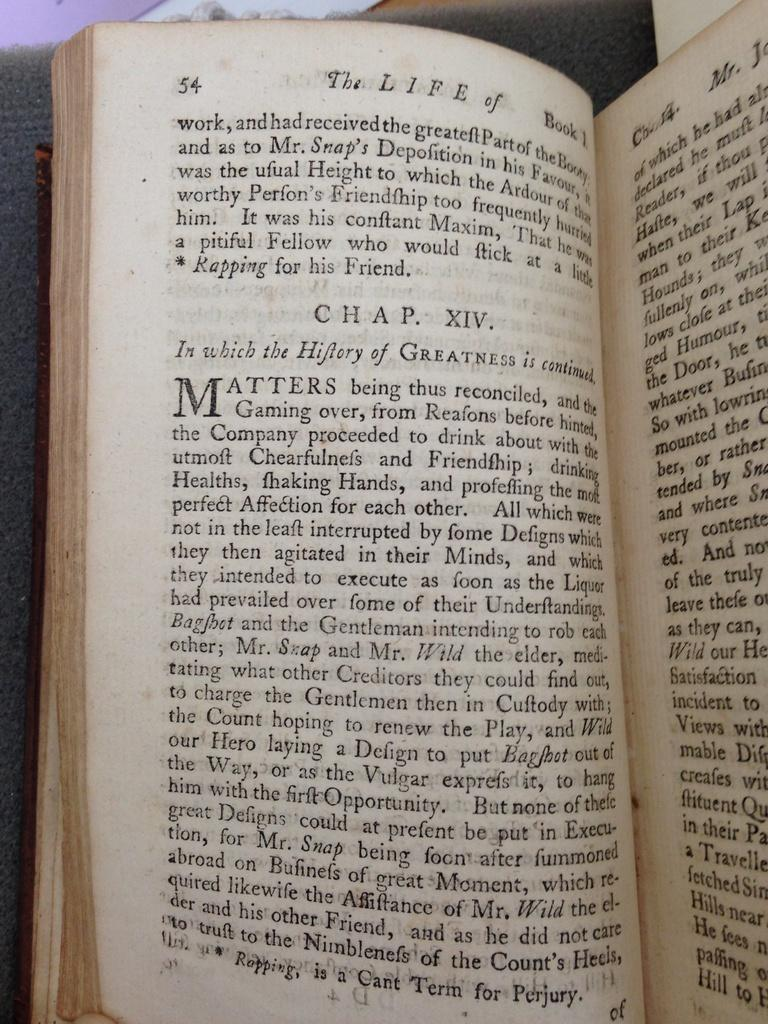<image>
Give a short and clear explanation of the subsequent image. Chapter XIV of this book starts on page 54. 